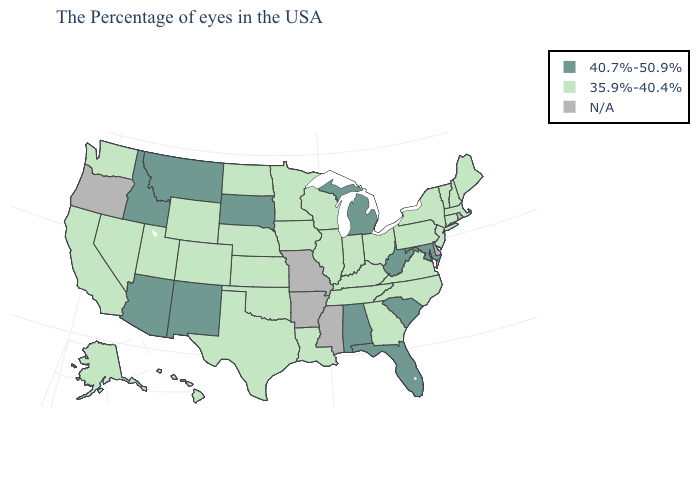Which states have the lowest value in the Northeast?
Write a very short answer. Maine, Massachusetts, New Hampshire, Vermont, Connecticut, New York, New Jersey, Pennsylvania. What is the value of Washington?
Concise answer only. 35.9%-40.4%. Does Michigan have the lowest value in the MidWest?
Keep it brief. No. Name the states that have a value in the range N/A?
Give a very brief answer. Rhode Island, Delaware, Mississippi, Missouri, Arkansas, Oregon. Which states hav the highest value in the Northeast?
Keep it brief. Maine, Massachusetts, New Hampshire, Vermont, Connecticut, New York, New Jersey, Pennsylvania. What is the value of West Virginia?
Quick response, please. 40.7%-50.9%. Is the legend a continuous bar?
Concise answer only. No. Does Alabama have the highest value in the USA?
Short answer required. Yes. Among the states that border Ohio , does Michigan have the lowest value?
Short answer required. No. What is the value of Rhode Island?
Be succinct. N/A. What is the lowest value in the South?
Give a very brief answer. 35.9%-40.4%. Does Kentucky have the highest value in the USA?
Write a very short answer. No. 